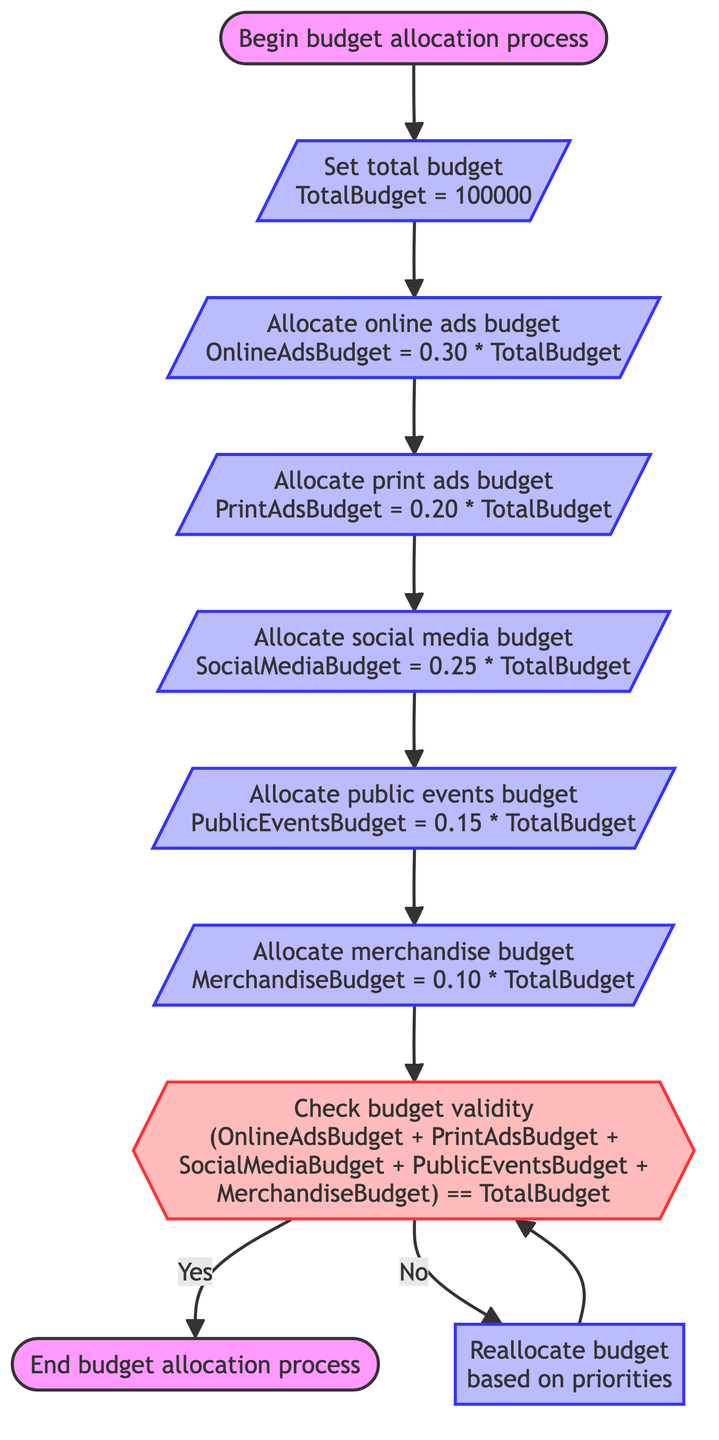What is the total budget set for the film festival? The diagram indicates that the total budget for the film festival is set at 100,000. This is stated in the node where the total budget is initialized.
Answer: 100000 How much of the total budget is allocated for online ads? The online ads budget is calculated as 30% of the total budget. Thus, OnlineAdsBudget = 0.30 * 100,000, resulting in 30,000 allocated for online ads.
Answer: 30000 What percentage of the total budget is allocated for social media influencers? The percentage allocated for social media influencers is stated as 25% in its respective node. This can be directly referenced from the flowchart's calculations.
Answer: 25% What happens if the total allocations do not match the budget? If the total allocations do not match the budget (i.e., the condition is false), the flowchart indicates that the process will redirect to the "Reallocate budget" node to adjust the budget based on specific campaign needs.
Answer: Reallocate budget How many types of promotional activities are budgeted? The flowchart outlines five types of promotional activities: online ads, print ads, social media, public events, and merchandise. Each type is represented in separate nodes.
Answer: Five What is the first step in the budget allocation process? The first step in the budget allocation process is indicated by the "Start" node, which leads to setting the total budget. It signifies the beginning of the entire process.
Answer: Begin budget allocation process If the budget is properly allocated, what is the next node after checking budget validity? If the budget is properly allocated (the condition is true), the next node after checking budget validity is the "End" node, indicating the completion of the budget allocation process.
Answer: End How is the budget allocated for events and screenings? The budget for public events and screenings is calculated as 15% of the total budget, which is specified in the respective node allocation process. This calculation can be directly referenced.
Answer: PublicEventsBudget = 15% 